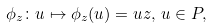<formula> <loc_0><loc_0><loc_500><loc_500>\phi _ { z } \colon u \mapsto \phi _ { z } ( u ) = u z , \, u \in P ,</formula> 